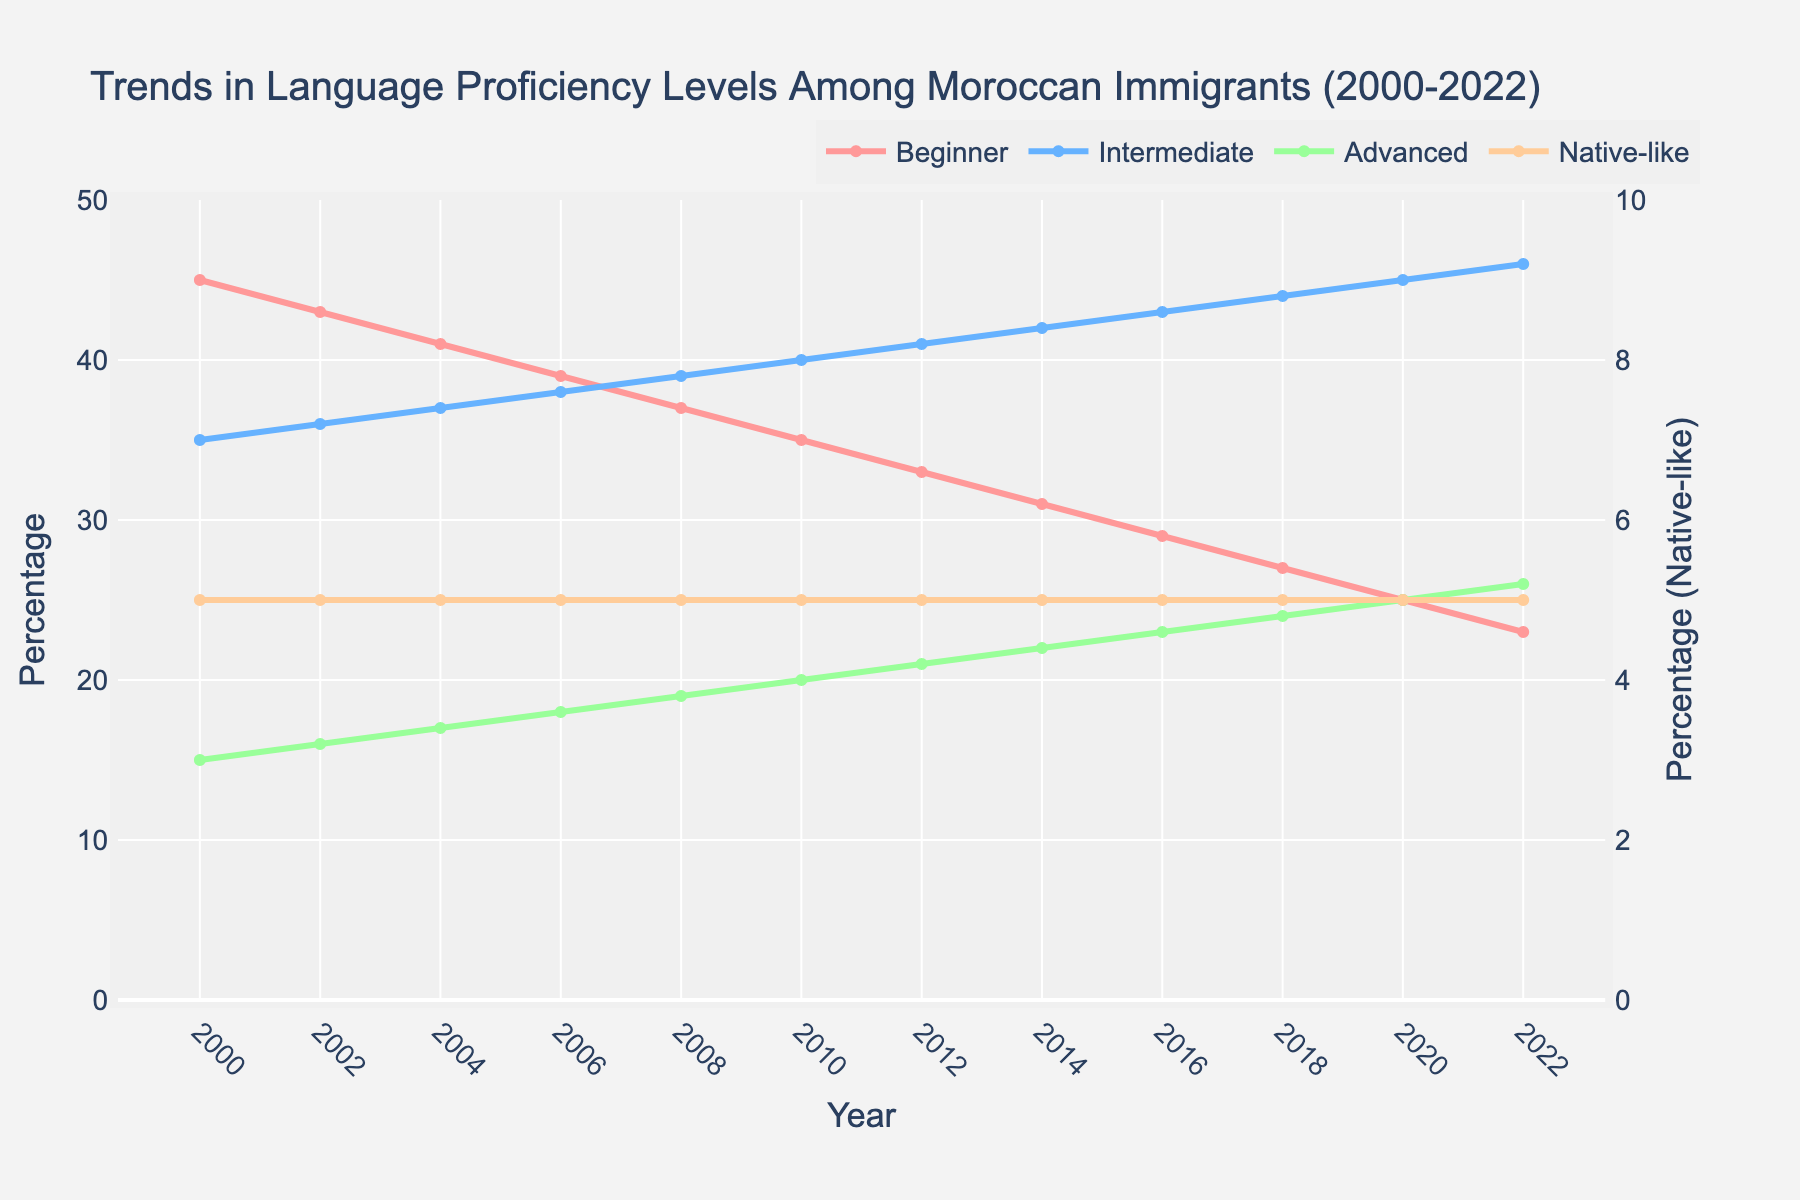What was the percentage of Moroccan immigrants at the Beginner level in 2008? The percentage at the Beginner level in 2008 is indicated on the chart. Find the year 2008 on the x-axis and trace up to the red line which represents Beginner level. The value there is 37%.
Answer: 37% What is the trend for the Intermediate level from 2000 to 2022? The trend for Intermediate level can be determined by looking at the light blue line from 2000 to 2022. The line shows a consistent increase over the years.
Answer: Increasing Which proficiency level had the least change in percentage from 2000 to 2022? Identify which line on the chart remained the most stable over the years. The light orange line representing Native-like has a consistent value of around 5% throughout the years.
Answer: Native-like How much did the percentage of Moroccan immigrants at the Advanced level increase from 2000 to 2022? To find the increase, subtract the 2000 value from the 2022 value for the Advanced level. In 2000 the value was 15% and in 2022 it was 26%, so the increase is 26% - 15% = 11%.
Answer: 11% Which proficiency level saw the largest decrease from 2000 to 2022? Compare the initial and final values for each proficiency level. The Beginner level had the largest decrease from 45% in 2000 to 23% in 2022, a difference of 22%.
Answer: Beginner What is the difference in percentage between Intermediate and Advanced levels in 2016? Find values for Intermediate and Advanced levels in 2016 and subtract the Advanced value from the Intermediate value. The percentage for Intermediate was 43%, and for Advanced it was 23%, so the difference is 43% - 23% = 20%.
Answer: 20% In which year did the percentage of Intermediate level Moroccan immigrants reach 40%? Follow the light blue line until it hits 40% on the y-axis. This occurs in the year 2010.
Answer: 2010 What visual indicates the percentage of Native-like proficiency level Moroccan immigrants? The Native-like proficiency level is represented by the light orange line.
Answer: Light orange line What is the average percentage of Moroccan immigrants at the Native-like level from 2000 to 2022? Add up the percentages for Native-like from 2000 to 2022 and then divide by the number of years (12). The total is (5+5+5+5+5+5+5+5+5+5+5+5) = 60, so the average is 60/12 = 5%.
Answer: 5% What percentage of Moroccan immigrants was at the Advanced level in 2014, and how does it compare to the percentage at the Intermediate level in the same year? Check the data for 2014 in the figure. The percentage at the Advanced level was 22%, and for the Intermediate level, it was 42%. Comparing them: Intermediate had 20% more than Advanced.
Answer: Advanced: 22%, Intermediate: 20% more 